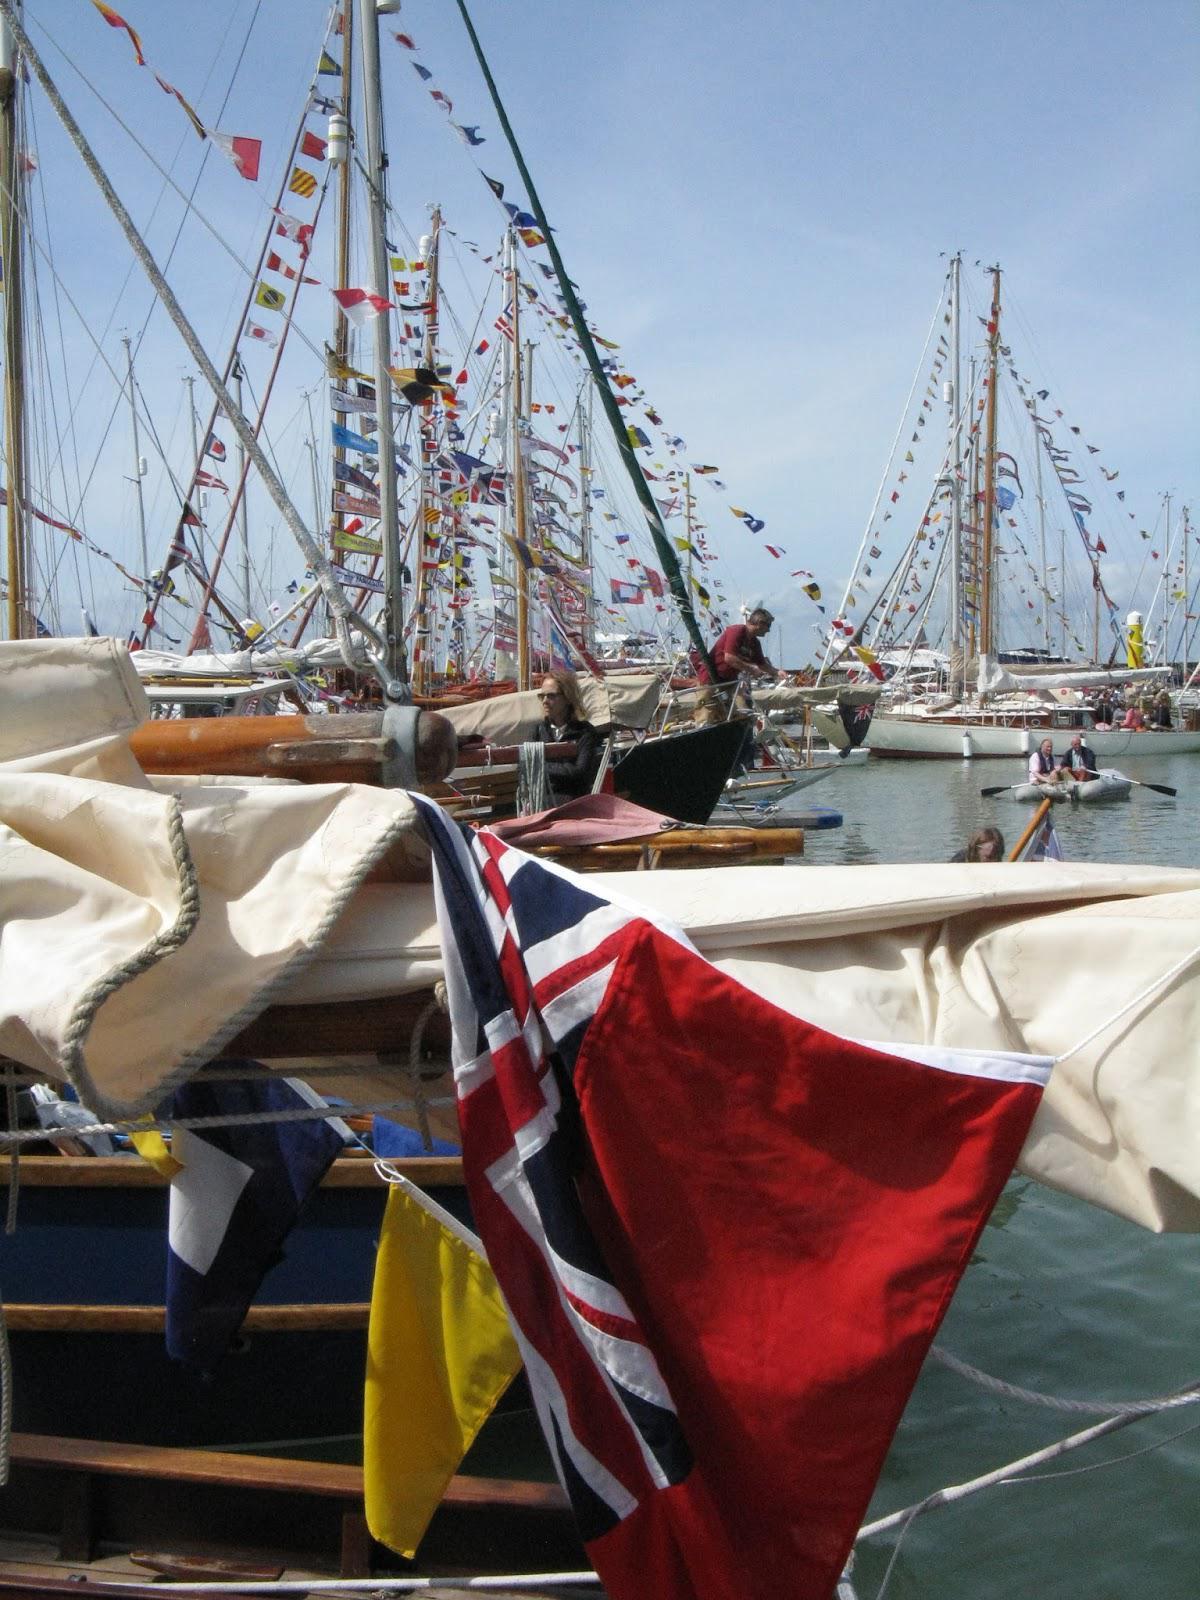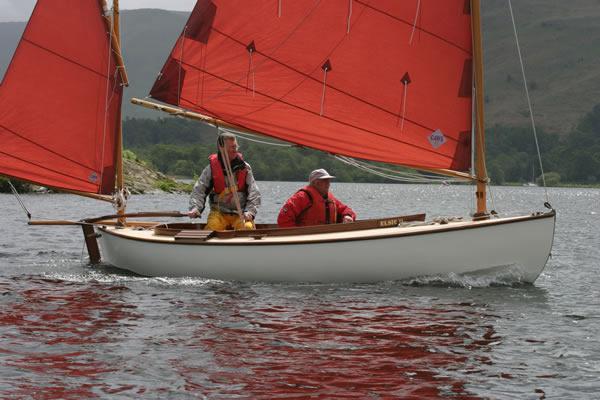The first image is the image on the left, the second image is the image on the right. Given the left and right images, does the statement "A sailboat on open water in one image has red sails and at least one person on the boat." hold true? Answer yes or no. Yes. The first image is the image on the left, the second image is the image on the right. Analyze the images presented: Is the assertion "n at least one image there are two red sails on a boat in the water." valid? Answer yes or no. Yes. 